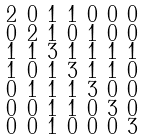Convert formula to latex. <formula><loc_0><loc_0><loc_500><loc_500>\begin{smallmatrix} 2 & 0 & 1 & 1 & 0 & 0 & 0 \\ 0 & 2 & 1 & 0 & 1 & 0 & 0 \\ 1 & 1 & 3 & 1 & 1 & 1 & 1 \\ 1 & 0 & 1 & 3 & 1 & 1 & 0 \\ 0 & 1 & 1 & 1 & 3 & 0 & 0 \\ 0 & 0 & 1 & 1 & 0 & 3 & 0 \\ 0 & 0 & 1 & 0 & 0 & 0 & 3 \end{smallmatrix}</formula> 